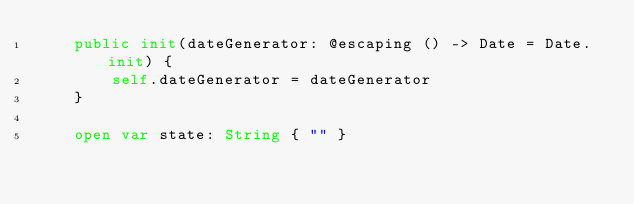Convert code to text. <code><loc_0><loc_0><loc_500><loc_500><_Swift_>    public init(dateGenerator: @escaping () -> Date = Date.init) {
        self.dateGenerator = dateGenerator
    }

    open var state: String { "" }
</code> 